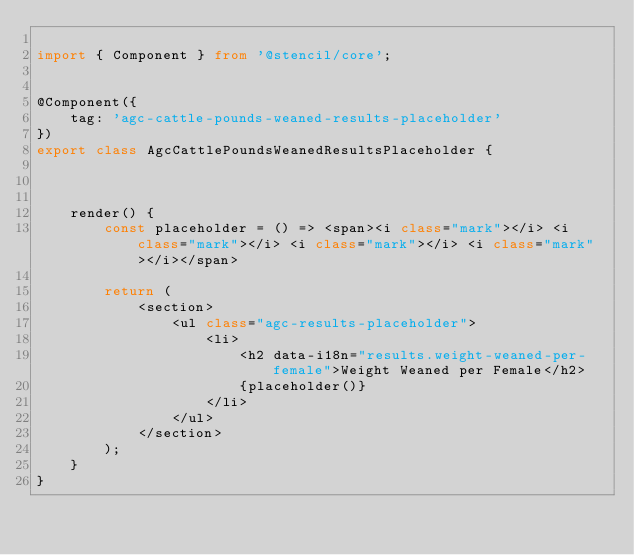Convert code to text. <code><loc_0><loc_0><loc_500><loc_500><_TypeScript_>
import { Component } from '@stencil/core';


@Component({
    tag: 'agc-cattle-pounds-weaned-results-placeholder'
})
export class AgcCattlePoundsWeanedResultsPlaceholder {

    

    render() {
        const placeholder = () => <span><i class="mark"></i> <i class="mark"></i> <i class="mark"></i> <i class="mark"></i></span>

        return (
            <section>
                <ul class="agc-results-placeholder">
                    <li>
                        <h2 data-i18n="results.weight-weaned-per-female">Weight Weaned per Female</h2>
                        {placeholder()}
                    </li>                                      
                </ul>
            </section>
        );
    }
}</code> 